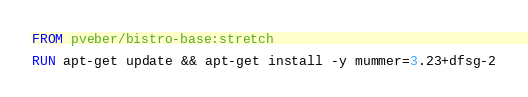<code> <loc_0><loc_0><loc_500><loc_500><_Dockerfile_>FROM pveber/bistro-base:stretch

RUN apt-get update && apt-get install -y mummer=3.23+dfsg-2

</code> 